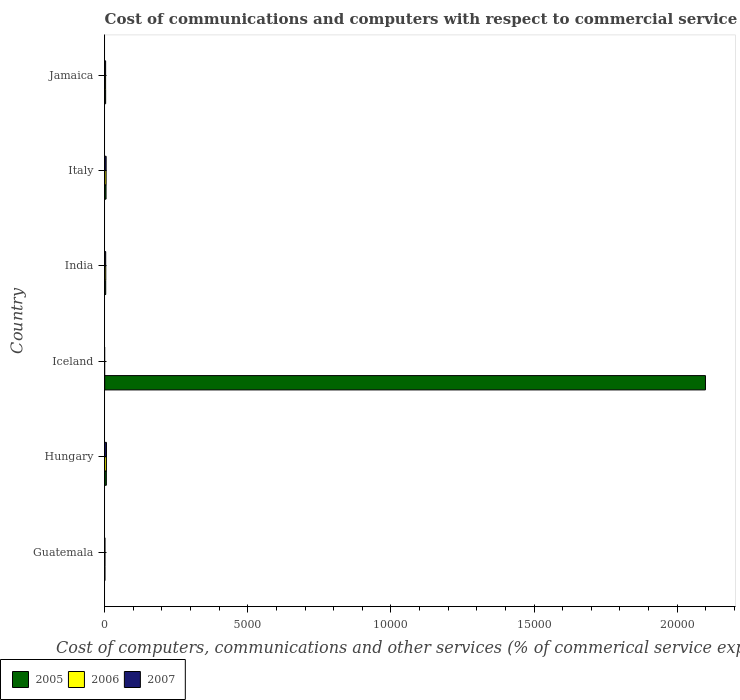How many different coloured bars are there?
Keep it short and to the point. 3. Are the number of bars per tick equal to the number of legend labels?
Offer a very short reply. No. Are the number of bars on each tick of the Y-axis equal?
Your response must be concise. No. How many bars are there on the 1st tick from the bottom?
Give a very brief answer. 3. What is the label of the 1st group of bars from the top?
Keep it short and to the point. Jamaica. In how many cases, is the number of bars for a given country not equal to the number of legend labels?
Your response must be concise. 1. What is the cost of communications and computers in 2005 in Iceland?
Provide a short and direct response. 2.10e+04. Across all countries, what is the maximum cost of communications and computers in 2006?
Ensure brevity in your answer.  59.67. In which country was the cost of communications and computers in 2005 maximum?
Offer a terse response. Iceland. What is the total cost of communications and computers in 2007 in the graph?
Ensure brevity in your answer.  182.43. What is the difference between the cost of communications and computers in 2005 in Hungary and that in Italy?
Provide a short and direct response. 10.32. What is the difference between the cost of communications and computers in 2007 in Italy and the cost of communications and computers in 2006 in Guatemala?
Your answer should be compact. 43.2. What is the average cost of communications and computers in 2007 per country?
Provide a succinct answer. 30.41. What is the difference between the cost of communications and computers in 2006 and cost of communications and computers in 2007 in Italy?
Your answer should be very brief. -0.65. In how many countries, is the cost of communications and computers in 2005 greater than 19000 %?
Your answer should be compact. 1. What is the ratio of the cost of communications and computers in 2006 in Italy to that in Jamaica?
Provide a short and direct response. 1.61. What is the difference between the highest and the second highest cost of communications and computers in 2006?
Your answer should be compact. 10.54. What is the difference between the highest and the lowest cost of communications and computers in 2005?
Give a very brief answer. 2.10e+04. Are all the bars in the graph horizontal?
Make the answer very short. Yes. Does the graph contain any zero values?
Offer a terse response. Yes. Does the graph contain grids?
Provide a succinct answer. No. How many legend labels are there?
Your answer should be very brief. 3. What is the title of the graph?
Ensure brevity in your answer.  Cost of communications and computers with respect to commercial service imports. Does "1969" appear as one of the legend labels in the graph?
Give a very brief answer. No. What is the label or title of the X-axis?
Give a very brief answer. Cost of computers, communications and other services (% of commerical service exports). What is the Cost of computers, communications and other services (% of commerical service exports) of 2005 in Guatemala?
Your answer should be very brief. 5.89. What is the Cost of computers, communications and other services (% of commerical service exports) in 2006 in Guatemala?
Give a very brief answer. 6.58. What is the Cost of computers, communications and other services (% of commerical service exports) in 2007 in Guatemala?
Make the answer very short. 6.34. What is the Cost of computers, communications and other services (% of commerical service exports) of 2005 in Hungary?
Your answer should be compact. 56.61. What is the Cost of computers, communications and other services (% of commerical service exports) of 2006 in Hungary?
Provide a succinct answer. 59.67. What is the Cost of computers, communications and other services (% of commerical service exports) in 2007 in Hungary?
Your answer should be very brief. 60.46. What is the Cost of computers, communications and other services (% of commerical service exports) of 2005 in Iceland?
Your answer should be compact. 2.10e+04. What is the Cost of computers, communications and other services (% of commerical service exports) in 2007 in Iceland?
Give a very brief answer. 0. What is the Cost of computers, communications and other services (% of commerical service exports) in 2005 in India?
Your answer should be very brief. 35.18. What is the Cost of computers, communications and other services (% of commerical service exports) in 2006 in India?
Your answer should be very brief. 36.9. What is the Cost of computers, communications and other services (% of commerical service exports) of 2007 in India?
Provide a succinct answer. 34.18. What is the Cost of computers, communications and other services (% of commerical service exports) of 2005 in Italy?
Your answer should be compact. 46.28. What is the Cost of computers, communications and other services (% of commerical service exports) of 2006 in Italy?
Your response must be concise. 49.13. What is the Cost of computers, communications and other services (% of commerical service exports) in 2007 in Italy?
Make the answer very short. 49.78. What is the Cost of computers, communications and other services (% of commerical service exports) in 2005 in Jamaica?
Ensure brevity in your answer.  32.25. What is the Cost of computers, communications and other services (% of commerical service exports) of 2006 in Jamaica?
Provide a succinct answer. 30.45. What is the Cost of computers, communications and other services (% of commerical service exports) of 2007 in Jamaica?
Your answer should be compact. 31.67. Across all countries, what is the maximum Cost of computers, communications and other services (% of commerical service exports) in 2005?
Offer a very short reply. 2.10e+04. Across all countries, what is the maximum Cost of computers, communications and other services (% of commerical service exports) in 2006?
Ensure brevity in your answer.  59.67. Across all countries, what is the maximum Cost of computers, communications and other services (% of commerical service exports) of 2007?
Your answer should be compact. 60.46. Across all countries, what is the minimum Cost of computers, communications and other services (% of commerical service exports) of 2005?
Give a very brief answer. 5.89. Across all countries, what is the minimum Cost of computers, communications and other services (% of commerical service exports) of 2006?
Your answer should be compact. 0. Across all countries, what is the minimum Cost of computers, communications and other services (% of commerical service exports) in 2007?
Keep it short and to the point. 0. What is the total Cost of computers, communications and other services (% of commerical service exports) in 2005 in the graph?
Ensure brevity in your answer.  2.12e+04. What is the total Cost of computers, communications and other services (% of commerical service exports) of 2006 in the graph?
Provide a short and direct response. 182.73. What is the total Cost of computers, communications and other services (% of commerical service exports) of 2007 in the graph?
Give a very brief answer. 182.43. What is the difference between the Cost of computers, communications and other services (% of commerical service exports) in 2005 in Guatemala and that in Hungary?
Keep it short and to the point. -50.71. What is the difference between the Cost of computers, communications and other services (% of commerical service exports) in 2006 in Guatemala and that in Hungary?
Provide a succinct answer. -53.09. What is the difference between the Cost of computers, communications and other services (% of commerical service exports) in 2007 in Guatemala and that in Hungary?
Offer a terse response. -54.13. What is the difference between the Cost of computers, communications and other services (% of commerical service exports) of 2005 in Guatemala and that in Iceland?
Make the answer very short. -2.10e+04. What is the difference between the Cost of computers, communications and other services (% of commerical service exports) of 2005 in Guatemala and that in India?
Keep it short and to the point. -29.28. What is the difference between the Cost of computers, communications and other services (% of commerical service exports) of 2006 in Guatemala and that in India?
Your response must be concise. -30.32. What is the difference between the Cost of computers, communications and other services (% of commerical service exports) in 2007 in Guatemala and that in India?
Give a very brief answer. -27.85. What is the difference between the Cost of computers, communications and other services (% of commerical service exports) in 2005 in Guatemala and that in Italy?
Offer a terse response. -40.39. What is the difference between the Cost of computers, communications and other services (% of commerical service exports) in 2006 in Guatemala and that in Italy?
Offer a terse response. -42.55. What is the difference between the Cost of computers, communications and other services (% of commerical service exports) of 2007 in Guatemala and that in Italy?
Your answer should be very brief. -43.45. What is the difference between the Cost of computers, communications and other services (% of commerical service exports) in 2005 in Guatemala and that in Jamaica?
Offer a terse response. -26.36. What is the difference between the Cost of computers, communications and other services (% of commerical service exports) in 2006 in Guatemala and that in Jamaica?
Provide a succinct answer. -23.87. What is the difference between the Cost of computers, communications and other services (% of commerical service exports) in 2007 in Guatemala and that in Jamaica?
Your response must be concise. -25.33. What is the difference between the Cost of computers, communications and other services (% of commerical service exports) of 2005 in Hungary and that in Iceland?
Provide a short and direct response. -2.09e+04. What is the difference between the Cost of computers, communications and other services (% of commerical service exports) in 2005 in Hungary and that in India?
Your response must be concise. 21.43. What is the difference between the Cost of computers, communications and other services (% of commerical service exports) of 2006 in Hungary and that in India?
Provide a short and direct response. 22.77. What is the difference between the Cost of computers, communications and other services (% of commerical service exports) in 2007 in Hungary and that in India?
Your answer should be compact. 26.28. What is the difference between the Cost of computers, communications and other services (% of commerical service exports) of 2005 in Hungary and that in Italy?
Provide a succinct answer. 10.32. What is the difference between the Cost of computers, communications and other services (% of commerical service exports) of 2006 in Hungary and that in Italy?
Offer a terse response. 10.54. What is the difference between the Cost of computers, communications and other services (% of commerical service exports) in 2007 in Hungary and that in Italy?
Provide a short and direct response. 10.68. What is the difference between the Cost of computers, communications and other services (% of commerical service exports) in 2005 in Hungary and that in Jamaica?
Your answer should be compact. 24.35. What is the difference between the Cost of computers, communications and other services (% of commerical service exports) of 2006 in Hungary and that in Jamaica?
Keep it short and to the point. 29.22. What is the difference between the Cost of computers, communications and other services (% of commerical service exports) of 2007 in Hungary and that in Jamaica?
Keep it short and to the point. 28.79. What is the difference between the Cost of computers, communications and other services (% of commerical service exports) in 2005 in Iceland and that in India?
Keep it short and to the point. 2.10e+04. What is the difference between the Cost of computers, communications and other services (% of commerical service exports) in 2005 in Iceland and that in Italy?
Provide a succinct answer. 2.09e+04. What is the difference between the Cost of computers, communications and other services (% of commerical service exports) of 2005 in Iceland and that in Jamaica?
Ensure brevity in your answer.  2.10e+04. What is the difference between the Cost of computers, communications and other services (% of commerical service exports) of 2005 in India and that in Italy?
Your answer should be very brief. -11.11. What is the difference between the Cost of computers, communications and other services (% of commerical service exports) in 2006 in India and that in Italy?
Provide a succinct answer. -12.23. What is the difference between the Cost of computers, communications and other services (% of commerical service exports) in 2007 in India and that in Italy?
Make the answer very short. -15.6. What is the difference between the Cost of computers, communications and other services (% of commerical service exports) of 2005 in India and that in Jamaica?
Make the answer very short. 2.92. What is the difference between the Cost of computers, communications and other services (% of commerical service exports) of 2006 in India and that in Jamaica?
Ensure brevity in your answer.  6.45. What is the difference between the Cost of computers, communications and other services (% of commerical service exports) in 2007 in India and that in Jamaica?
Provide a succinct answer. 2.51. What is the difference between the Cost of computers, communications and other services (% of commerical service exports) of 2005 in Italy and that in Jamaica?
Your response must be concise. 14.03. What is the difference between the Cost of computers, communications and other services (% of commerical service exports) of 2006 in Italy and that in Jamaica?
Your response must be concise. 18.68. What is the difference between the Cost of computers, communications and other services (% of commerical service exports) in 2007 in Italy and that in Jamaica?
Give a very brief answer. 18.11. What is the difference between the Cost of computers, communications and other services (% of commerical service exports) of 2005 in Guatemala and the Cost of computers, communications and other services (% of commerical service exports) of 2006 in Hungary?
Your answer should be very brief. -53.78. What is the difference between the Cost of computers, communications and other services (% of commerical service exports) of 2005 in Guatemala and the Cost of computers, communications and other services (% of commerical service exports) of 2007 in Hungary?
Your answer should be very brief. -54.57. What is the difference between the Cost of computers, communications and other services (% of commerical service exports) of 2006 in Guatemala and the Cost of computers, communications and other services (% of commerical service exports) of 2007 in Hungary?
Ensure brevity in your answer.  -53.88. What is the difference between the Cost of computers, communications and other services (% of commerical service exports) of 2005 in Guatemala and the Cost of computers, communications and other services (% of commerical service exports) of 2006 in India?
Keep it short and to the point. -31. What is the difference between the Cost of computers, communications and other services (% of commerical service exports) in 2005 in Guatemala and the Cost of computers, communications and other services (% of commerical service exports) in 2007 in India?
Your answer should be very brief. -28.29. What is the difference between the Cost of computers, communications and other services (% of commerical service exports) of 2006 in Guatemala and the Cost of computers, communications and other services (% of commerical service exports) of 2007 in India?
Provide a short and direct response. -27.6. What is the difference between the Cost of computers, communications and other services (% of commerical service exports) of 2005 in Guatemala and the Cost of computers, communications and other services (% of commerical service exports) of 2006 in Italy?
Provide a succinct answer. -43.24. What is the difference between the Cost of computers, communications and other services (% of commerical service exports) of 2005 in Guatemala and the Cost of computers, communications and other services (% of commerical service exports) of 2007 in Italy?
Provide a short and direct response. -43.89. What is the difference between the Cost of computers, communications and other services (% of commerical service exports) of 2006 in Guatemala and the Cost of computers, communications and other services (% of commerical service exports) of 2007 in Italy?
Keep it short and to the point. -43.2. What is the difference between the Cost of computers, communications and other services (% of commerical service exports) in 2005 in Guatemala and the Cost of computers, communications and other services (% of commerical service exports) in 2006 in Jamaica?
Ensure brevity in your answer.  -24.56. What is the difference between the Cost of computers, communications and other services (% of commerical service exports) of 2005 in Guatemala and the Cost of computers, communications and other services (% of commerical service exports) of 2007 in Jamaica?
Give a very brief answer. -25.78. What is the difference between the Cost of computers, communications and other services (% of commerical service exports) in 2006 in Guatemala and the Cost of computers, communications and other services (% of commerical service exports) in 2007 in Jamaica?
Give a very brief answer. -25.09. What is the difference between the Cost of computers, communications and other services (% of commerical service exports) in 2005 in Hungary and the Cost of computers, communications and other services (% of commerical service exports) in 2006 in India?
Your answer should be compact. 19.71. What is the difference between the Cost of computers, communications and other services (% of commerical service exports) of 2005 in Hungary and the Cost of computers, communications and other services (% of commerical service exports) of 2007 in India?
Provide a succinct answer. 22.42. What is the difference between the Cost of computers, communications and other services (% of commerical service exports) in 2006 in Hungary and the Cost of computers, communications and other services (% of commerical service exports) in 2007 in India?
Provide a short and direct response. 25.49. What is the difference between the Cost of computers, communications and other services (% of commerical service exports) in 2005 in Hungary and the Cost of computers, communications and other services (% of commerical service exports) in 2006 in Italy?
Give a very brief answer. 7.48. What is the difference between the Cost of computers, communications and other services (% of commerical service exports) in 2005 in Hungary and the Cost of computers, communications and other services (% of commerical service exports) in 2007 in Italy?
Keep it short and to the point. 6.82. What is the difference between the Cost of computers, communications and other services (% of commerical service exports) in 2006 in Hungary and the Cost of computers, communications and other services (% of commerical service exports) in 2007 in Italy?
Provide a succinct answer. 9.89. What is the difference between the Cost of computers, communications and other services (% of commerical service exports) of 2005 in Hungary and the Cost of computers, communications and other services (% of commerical service exports) of 2006 in Jamaica?
Your answer should be very brief. 26.16. What is the difference between the Cost of computers, communications and other services (% of commerical service exports) of 2005 in Hungary and the Cost of computers, communications and other services (% of commerical service exports) of 2007 in Jamaica?
Your response must be concise. 24.94. What is the difference between the Cost of computers, communications and other services (% of commerical service exports) in 2006 in Hungary and the Cost of computers, communications and other services (% of commerical service exports) in 2007 in Jamaica?
Give a very brief answer. 28. What is the difference between the Cost of computers, communications and other services (% of commerical service exports) in 2005 in Iceland and the Cost of computers, communications and other services (% of commerical service exports) in 2006 in India?
Keep it short and to the point. 2.10e+04. What is the difference between the Cost of computers, communications and other services (% of commerical service exports) of 2005 in Iceland and the Cost of computers, communications and other services (% of commerical service exports) of 2007 in India?
Make the answer very short. 2.10e+04. What is the difference between the Cost of computers, communications and other services (% of commerical service exports) in 2005 in Iceland and the Cost of computers, communications and other services (% of commerical service exports) in 2006 in Italy?
Provide a short and direct response. 2.09e+04. What is the difference between the Cost of computers, communications and other services (% of commerical service exports) in 2005 in Iceland and the Cost of computers, communications and other services (% of commerical service exports) in 2007 in Italy?
Make the answer very short. 2.09e+04. What is the difference between the Cost of computers, communications and other services (% of commerical service exports) of 2005 in Iceland and the Cost of computers, communications and other services (% of commerical service exports) of 2006 in Jamaica?
Keep it short and to the point. 2.10e+04. What is the difference between the Cost of computers, communications and other services (% of commerical service exports) in 2005 in Iceland and the Cost of computers, communications and other services (% of commerical service exports) in 2007 in Jamaica?
Your response must be concise. 2.10e+04. What is the difference between the Cost of computers, communications and other services (% of commerical service exports) of 2005 in India and the Cost of computers, communications and other services (% of commerical service exports) of 2006 in Italy?
Ensure brevity in your answer.  -13.95. What is the difference between the Cost of computers, communications and other services (% of commerical service exports) in 2005 in India and the Cost of computers, communications and other services (% of commerical service exports) in 2007 in Italy?
Provide a short and direct response. -14.61. What is the difference between the Cost of computers, communications and other services (% of commerical service exports) in 2006 in India and the Cost of computers, communications and other services (% of commerical service exports) in 2007 in Italy?
Make the answer very short. -12.89. What is the difference between the Cost of computers, communications and other services (% of commerical service exports) in 2005 in India and the Cost of computers, communications and other services (% of commerical service exports) in 2006 in Jamaica?
Your answer should be compact. 4.73. What is the difference between the Cost of computers, communications and other services (% of commerical service exports) in 2005 in India and the Cost of computers, communications and other services (% of commerical service exports) in 2007 in Jamaica?
Offer a very short reply. 3.51. What is the difference between the Cost of computers, communications and other services (% of commerical service exports) in 2006 in India and the Cost of computers, communications and other services (% of commerical service exports) in 2007 in Jamaica?
Offer a very short reply. 5.23. What is the difference between the Cost of computers, communications and other services (% of commerical service exports) in 2005 in Italy and the Cost of computers, communications and other services (% of commerical service exports) in 2006 in Jamaica?
Your answer should be very brief. 15.83. What is the difference between the Cost of computers, communications and other services (% of commerical service exports) in 2005 in Italy and the Cost of computers, communications and other services (% of commerical service exports) in 2007 in Jamaica?
Keep it short and to the point. 14.61. What is the difference between the Cost of computers, communications and other services (% of commerical service exports) in 2006 in Italy and the Cost of computers, communications and other services (% of commerical service exports) in 2007 in Jamaica?
Your answer should be compact. 17.46. What is the average Cost of computers, communications and other services (% of commerical service exports) of 2005 per country?
Make the answer very short. 3527.79. What is the average Cost of computers, communications and other services (% of commerical service exports) of 2006 per country?
Give a very brief answer. 30.45. What is the average Cost of computers, communications and other services (% of commerical service exports) in 2007 per country?
Offer a terse response. 30.41. What is the difference between the Cost of computers, communications and other services (% of commerical service exports) in 2005 and Cost of computers, communications and other services (% of commerical service exports) in 2006 in Guatemala?
Offer a very short reply. -0.69. What is the difference between the Cost of computers, communications and other services (% of commerical service exports) of 2005 and Cost of computers, communications and other services (% of commerical service exports) of 2007 in Guatemala?
Your response must be concise. -0.44. What is the difference between the Cost of computers, communications and other services (% of commerical service exports) in 2006 and Cost of computers, communications and other services (% of commerical service exports) in 2007 in Guatemala?
Make the answer very short. 0.25. What is the difference between the Cost of computers, communications and other services (% of commerical service exports) in 2005 and Cost of computers, communications and other services (% of commerical service exports) in 2006 in Hungary?
Ensure brevity in your answer.  -3.06. What is the difference between the Cost of computers, communications and other services (% of commerical service exports) in 2005 and Cost of computers, communications and other services (% of commerical service exports) in 2007 in Hungary?
Your response must be concise. -3.86. What is the difference between the Cost of computers, communications and other services (% of commerical service exports) in 2006 and Cost of computers, communications and other services (% of commerical service exports) in 2007 in Hungary?
Provide a succinct answer. -0.79. What is the difference between the Cost of computers, communications and other services (% of commerical service exports) in 2005 and Cost of computers, communications and other services (% of commerical service exports) in 2006 in India?
Provide a succinct answer. -1.72. What is the difference between the Cost of computers, communications and other services (% of commerical service exports) of 2006 and Cost of computers, communications and other services (% of commerical service exports) of 2007 in India?
Offer a very short reply. 2.71. What is the difference between the Cost of computers, communications and other services (% of commerical service exports) of 2005 and Cost of computers, communications and other services (% of commerical service exports) of 2006 in Italy?
Provide a short and direct response. -2.85. What is the difference between the Cost of computers, communications and other services (% of commerical service exports) in 2005 and Cost of computers, communications and other services (% of commerical service exports) in 2007 in Italy?
Provide a short and direct response. -3.5. What is the difference between the Cost of computers, communications and other services (% of commerical service exports) in 2006 and Cost of computers, communications and other services (% of commerical service exports) in 2007 in Italy?
Offer a terse response. -0.65. What is the difference between the Cost of computers, communications and other services (% of commerical service exports) in 2005 and Cost of computers, communications and other services (% of commerical service exports) in 2006 in Jamaica?
Your response must be concise. 1.8. What is the difference between the Cost of computers, communications and other services (% of commerical service exports) of 2005 and Cost of computers, communications and other services (% of commerical service exports) of 2007 in Jamaica?
Give a very brief answer. 0.58. What is the difference between the Cost of computers, communications and other services (% of commerical service exports) in 2006 and Cost of computers, communications and other services (% of commerical service exports) in 2007 in Jamaica?
Ensure brevity in your answer.  -1.22. What is the ratio of the Cost of computers, communications and other services (% of commerical service exports) in 2005 in Guatemala to that in Hungary?
Offer a very short reply. 0.1. What is the ratio of the Cost of computers, communications and other services (% of commerical service exports) in 2006 in Guatemala to that in Hungary?
Provide a succinct answer. 0.11. What is the ratio of the Cost of computers, communications and other services (% of commerical service exports) of 2007 in Guatemala to that in Hungary?
Your answer should be very brief. 0.1. What is the ratio of the Cost of computers, communications and other services (% of commerical service exports) of 2005 in Guatemala to that in Iceland?
Offer a very short reply. 0. What is the ratio of the Cost of computers, communications and other services (% of commerical service exports) in 2005 in Guatemala to that in India?
Give a very brief answer. 0.17. What is the ratio of the Cost of computers, communications and other services (% of commerical service exports) in 2006 in Guatemala to that in India?
Your answer should be very brief. 0.18. What is the ratio of the Cost of computers, communications and other services (% of commerical service exports) in 2007 in Guatemala to that in India?
Offer a very short reply. 0.19. What is the ratio of the Cost of computers, communications and other services (% of commerical service exports) of 2005 in Guatemala to that in Italy?
Provide a short and direct response. 0.13. What is the ratio of the Cost of computers, communications and other services (% of commerical service exports) of 2006 in Guatemala to that in Italy?
Your response must be concise. 0.13. What is the ratio of the Cost of computers, communications and other services (% of commerical service exports) of 2007 in Guatemala to that in Italy?
Ensure brevity in your answer.  0.13. What is the ratio of the Cost of computers, communications and other services (% of commerical service exports) of 2005 in Guatemala to that in Jamaica?
Give a very brief answer. 0.18. What is the ratio of the Cost of computers, communications and other services (% of commerical service exports) of 2006 in Guatemala to that in Jamaica?
Offer a very short reply. 0.22. What is the ratio of the Cost of computers, communications and other services (% of commerical service exports) of 2007 in Guatemala to that in Jamaica?
Keep it short and to the point. 0.2. What is the ratio of the Cost of computers, communications and other services (% of commerical service exports) of 2005 in Hungary to that in Iceland?
Your answer should be very brief. 0. What is the ratio of the Cost of computers, communications and other services (% of commerical service exports) in 2005 in Hungary to that in India?
Provide a short and direct response. 1.61. What is the ratio of the Cost of computers, communications and other services (% of commerical service exports) in 2006 in Hungary to that in India?
Provide a short and direct response. 1.62. What is the ratio of the Cost of computers, communications and other services (% of commerical service exports) in 2007 in Hungary to that in India?
Make the answer very short. 1.77. What is the ratio of the Cost of computers, communications and other services (% of commerical service exports) in 2005 in Hungary to that in Italy?
Your response must be concise. 1.22. What is the ratio of the Cost of computers, communications and other services (% of commerical service exports) in 2006 in Hungary to that in Italy?
Offer a terse response. 1.21. What is the ratio of the Cost of computers, communications and other services (% of commerical service exports) in 2007 in Hungary to that in Italy?
Make the answer very short. 1.21. What is the ratio of the Cost of computers, communications and other services (% of commerical service exports) in 2005 in Hungary to that in Jamaica?
Ensure brevity in your answer.  1.75. What is the ratio of the Cost of computers, communications and other services (% of commerical service exports) in 2006 in Hungary to that in Jamaica?
Make the answer very short. 1.96. What is the ratio of the Cost of computers, communications and other services (% of commerical service exports) of 2007 in Hungary to that in Jamaica?
Your answer should be very brief. 1.91. What is the ratio of the Cost of computers, communications and other services (% of commerical service exports) of 2005 in Iceland to that in India?
Your response must be concise. 596.72. What is the ratio of the Cost of computers, communications and other services (% of commerical service exports) of 2005 in Iceland to that in Italy?
Provide a short and direct response. 453.52. What is the ratio of the Cost of computers, communications and other services (% of commerical service exports) in 2005 in Iceland to that in Jamaica?
Give a very brief answer. 650.8. What is the ratio of the Cost of computers, communications and other services (% of commerical service exports) in 2005 in India to that in Italy?
Give a very brief answer. 0.76. What is the ratio of the Cost of computers, communications and other services (% of commerical service exports) in 2006 in India to that in Italy?
Your answer should be compact. 0.75. What is the ratio of the Cost of computers, communications and other services (% of commerical service exports) in 2007 in India to that in Italy?
Offer a terse response. 0.69. What is the ratio of the Cost of computers, communications and other services (% of commerical service exports) in 2005 in India to that in Jamaica?
Your answer should be very brief. 1.09. What is the ratio of the Cost of computers, communications and other services (% of commerical service exports) of 2006 in India to that in Jamaica?
Offer a terse response. 1.21. What is the ratio of the Cost of computers, communications and other services (% of commerical service exports) in 2007 in India to that in Jamaica?
Keep it short and to the point. 1.08. What is the ratio of the Cost of computers, communications and other services (% of commerical service exports) in 2005 in Italy to that in Jamaica?
Keep it short and to the point. 1.44. What is the ratio of the Cost of computers, communications and other services (% of commerical service exports) of 2006 in Italy to that in Jamaica?
Provide a succinct answer. 1.61. What is the ratio of the Cost of computers, communications and other services (% of commerical service exports) of 2007 in Italy to that in Jamaica?
Offer a very short reply. 1.57. What is the difference between the highest and the second highest Cost of computers, communications and other services (% of commerical service exports) in 2005?
Provide a succinct answer. 2.09e+04. What is the difference between the highest and the second highest Cost of computers, communications and other services (% of commerical service exports) in 2006?
Make the answer very short. 10.54. What is the difference between the highest and the second highest Cost of computers, communications and other services (% of commerical service exports) in 2007?
Your answer should be very brief. 10.68. What is the difference between the highest and the lowest Cost of computers, communications and other services (% of commerical service exports) in 2005?
Make the answer very short. 2.10e+04. What is the difference between the highest and the lowest Cost of computers, communications and other services (% of commerical service exports) in 2006?
Give a very brief answer. 59.67. What is the difference between the highest and the lowest Cost of computers, communications and other services (% of commerical service exports) in 2007?
Provide a short and direct response. 60.46. 